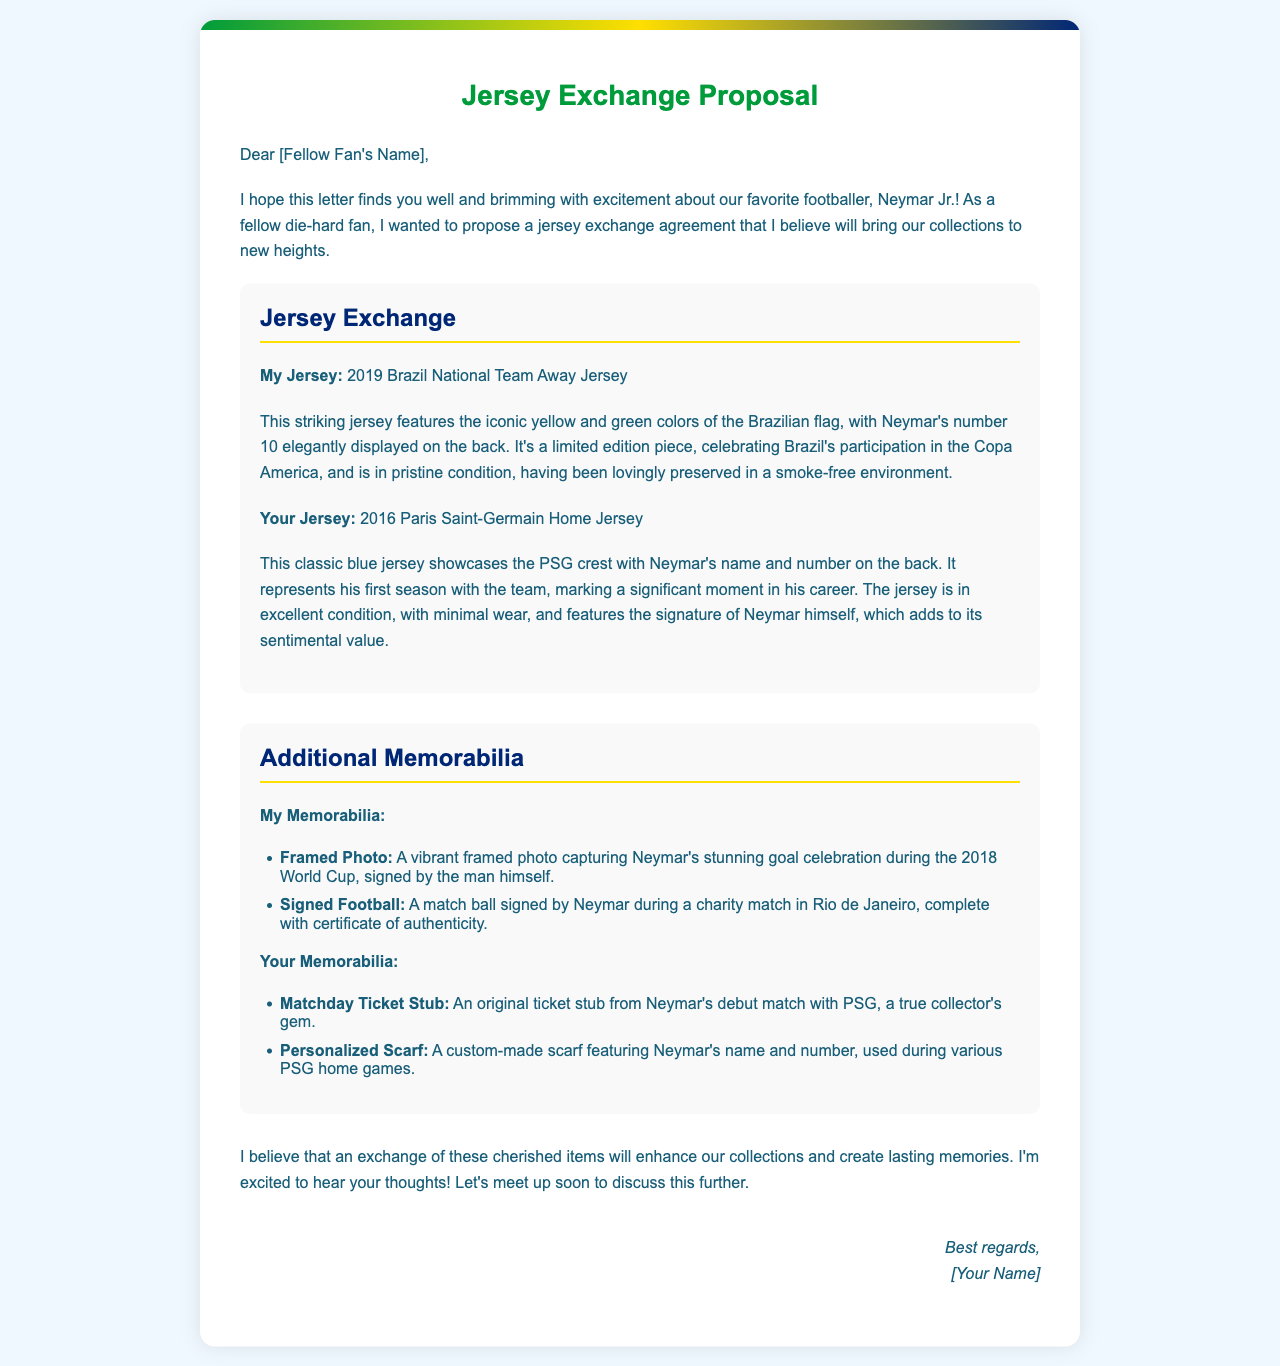What is the title of the letter? The title of the letter is presented at the top of the document in bold.
Answer: Jersey Exchange Proposal Who is the main subject of the letter? The letter is addressed to a fellow fan who shares a passion for a specific footballer.
Answer: Neymar Jr What year is the featured Brazil National Team jersey from? The jersey mentioned in the letter signifies a particular year that is referenced explicitly.
Answer: 2019 What significant event does the 2019 jersey commemorate? The letter specifies an event linked to Brazil's football history associated with the jersey.
Answer: Copa America What is the condition of the sender's memorabilia? The condition of the memorabilia is described within the letter, impacting its perceived value.
Answer: Excellent condition What is included with the signed football? The letter states an important authenticity feature that accompanies the signed item.
Answer: Certificate of authenticity What unique item does the recipient have from Neymar's PSG debut? The letter refers to a specific collectible that holds significance in the recipient's collection.
Answer: Matchday Ticket Stub How many items of memorabilia does the sender list? The letter provides a clear count of the memorabilia items being offered in the exchange.
Answer: Two items What type of jersey does the recipient possess? The document mentions a specific club and jersey type that the recipient has in their collection.
Answer: Paris Saint-Germain Home Jersey 